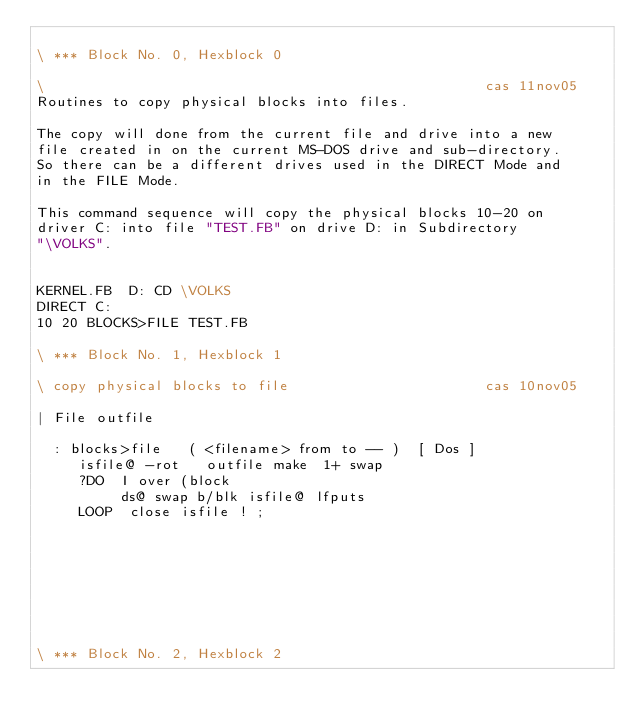Convert code to text. <code><loc_0><loc_0><loc_500><loc_500><_Forth_>
\ *** Block No. 0, Hexblock 0

\                                                    cas 11nov05
Routines to copy physical blocks into files.

The copy will done from the current file and drive into a new
file created in on the current MS-DOS drive and sub-directory.
So there can be a different drives used in the DIRECT Mode and
in the FILE Mode.

This command sequence will copy the physical blocks 10-20 on
driver C: into file "TEST.FB" on drive D: in Subdirectory
"\VOLKS".


KERNEL.FB  D: CD \VOLKS
DIRECT C:
10 20 BLOCKS>FILE TEST.FB

\ *** Block No. 1, Hexblock 1

\ copy physical blocks to file                       cas 10nov05

| File outfile

  : blocks>file   ( <filename> from to -- )  [ Dos ]
     isfile@ -rot   outfile make  1+ swap
     ?DO  I over (block
          ds@ swap b/blk isfile@ lfputs
     LOOP  close isfile ! ;








\ *** Block No. 2, Hexblock 2

















</code> 